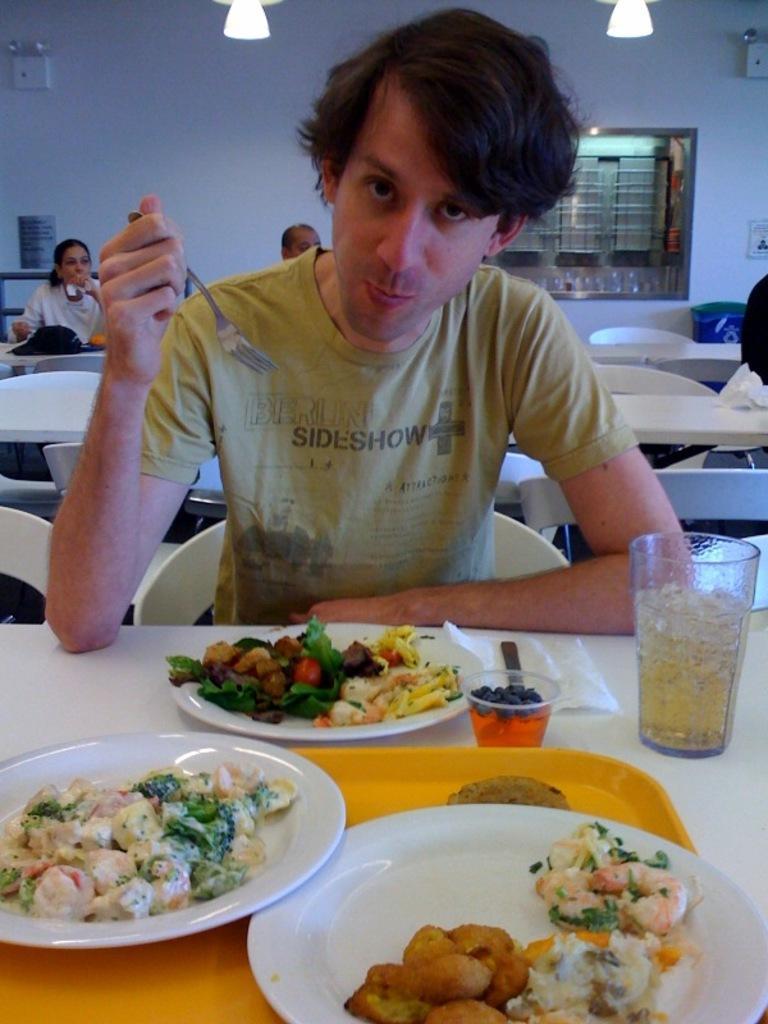Can you describe this image briefly? In this image there are tables and chairs. There are people sitting on the chairs. In the foreground there is a man sitting on a chair and holding a fork in his hand. In front of him there is a table. On the table there are plates, glasses, tissues, a tray and food. In the background there is a wall. There are windows to the wall. At the top there are lights to the ceiling. 